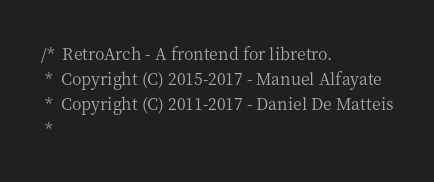<code> <loc_0><loc_0><loc_500><loc_500><_C_>/*  RetroArch - A frontend for libretro.
 *  Copyright (C) 2015-2017 - Manuel Alfayate
 *  Copyright (C) 2011-2017 - Daniel De Matteis
 *</code> 